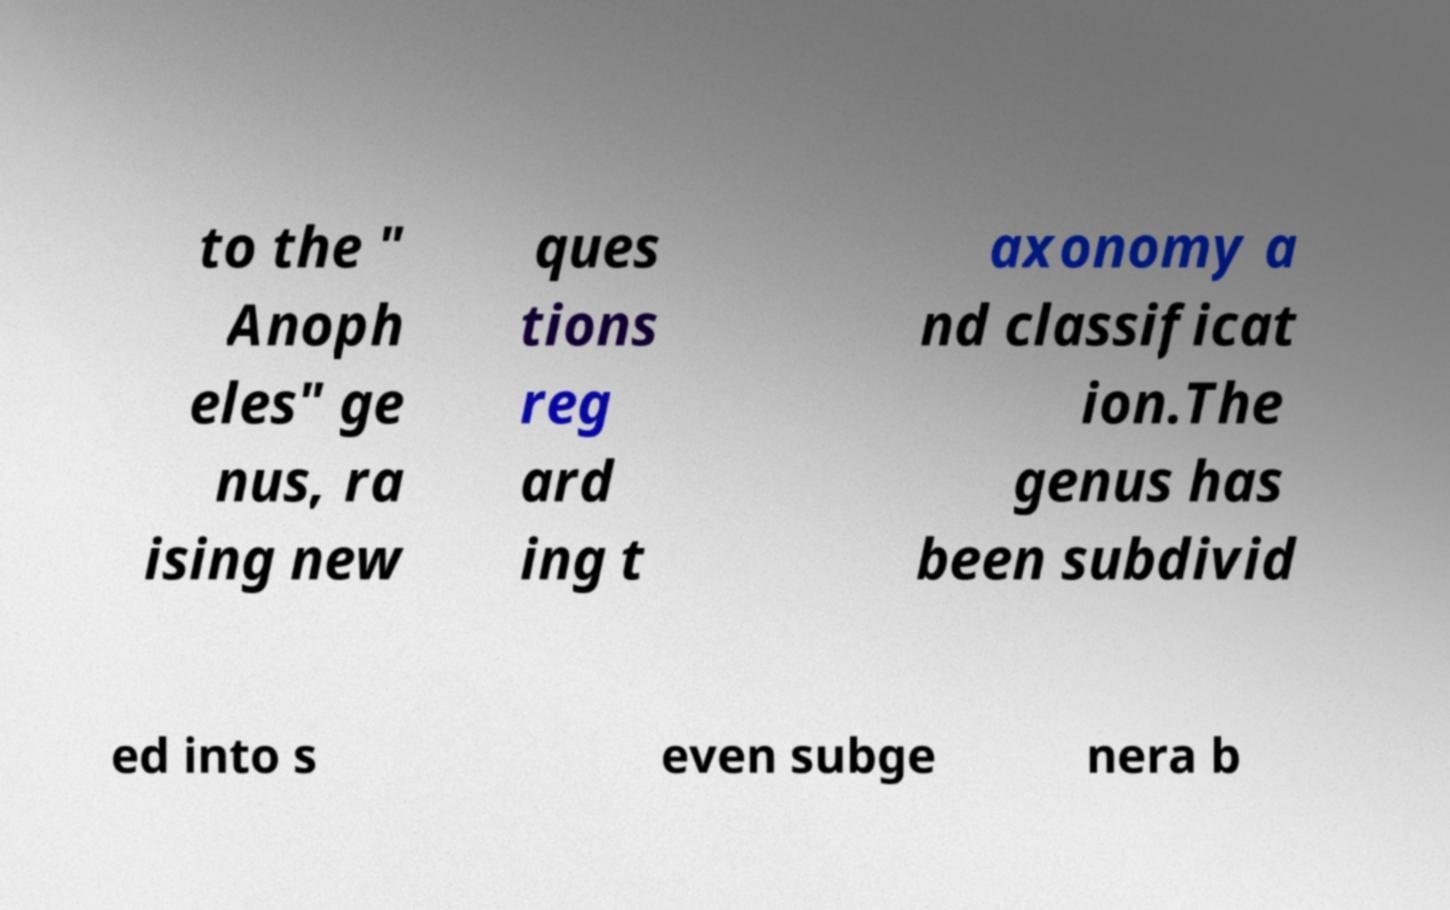Please read and relay the text visible in this image. What does it say? to the " Anoph eles" ge nus, ra ising new ques tions reg ard ing t axonomy a nd classificat ion.The genus has been subdivid ed into s even subge nera b 